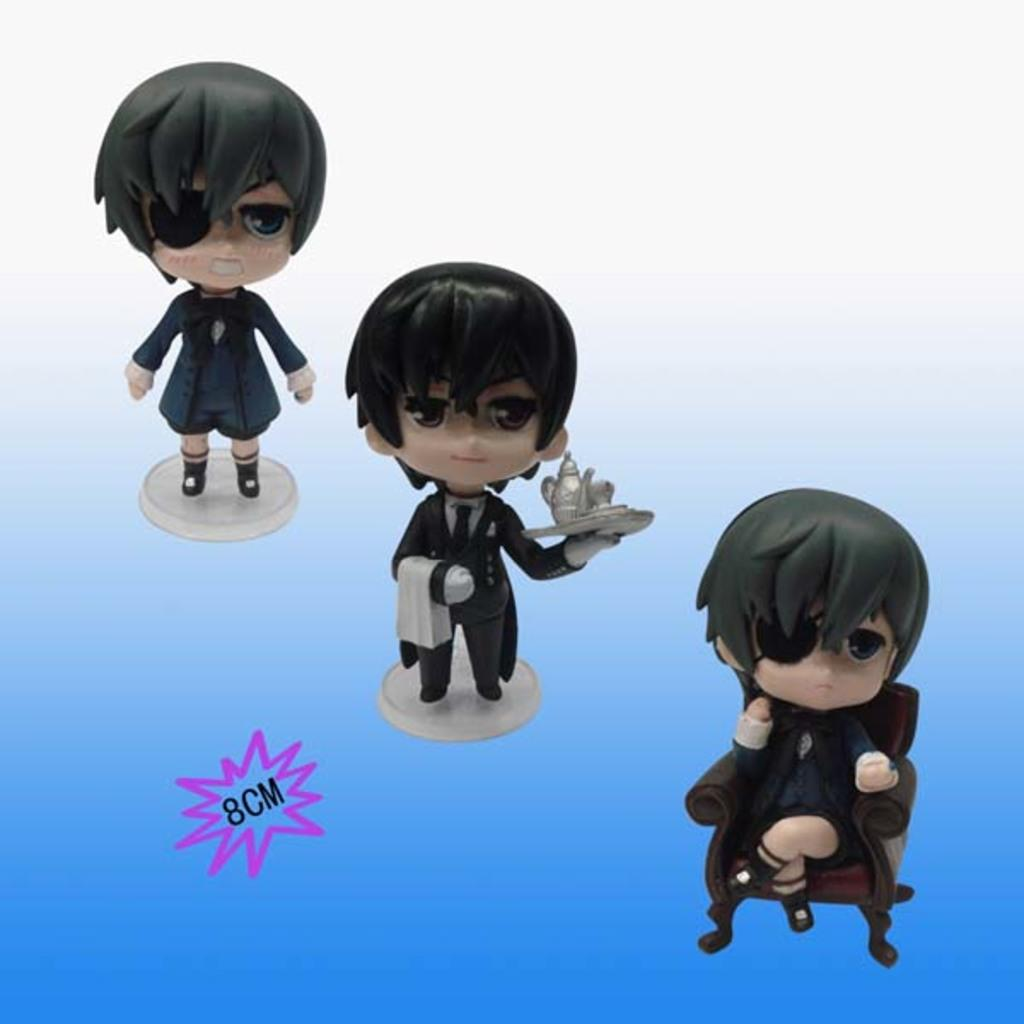What type of visual content is present in the image? There are cartoons in the image. Are there any written words or phrases in the image? Yes, there is text in the image. How many books are visible in the image? There are no books present in the image; it contains cartoons and text. What type of line can be seen connecting the cartoons in the image? There is no line connecting the cartoons in the image; it only contains cartoons and text. 